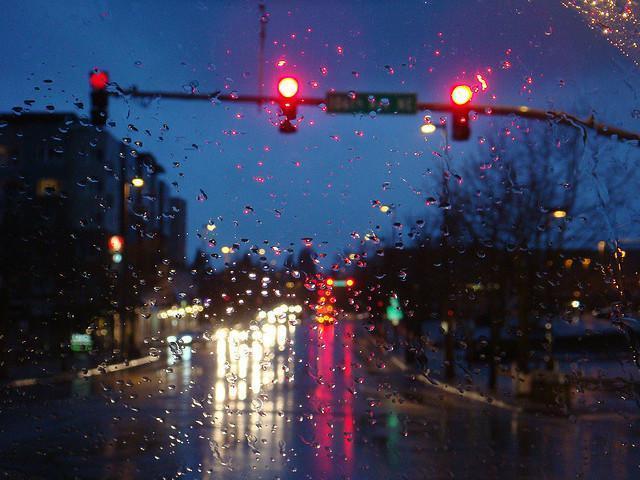How many lights are red?
Give a very brief answer. 3. How many horses have white on them?
Give a very brief answer. 0. 